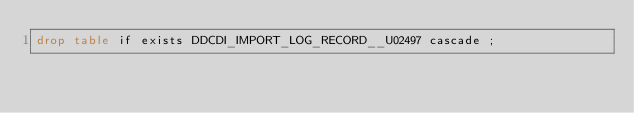Convert code to text. <code><loc_0><loc_0><loc_500><loc_500><_SQL_>drop table if exists DDCDI_IMPORT_LOG_RECORD__U02497 cascade ;</code> 